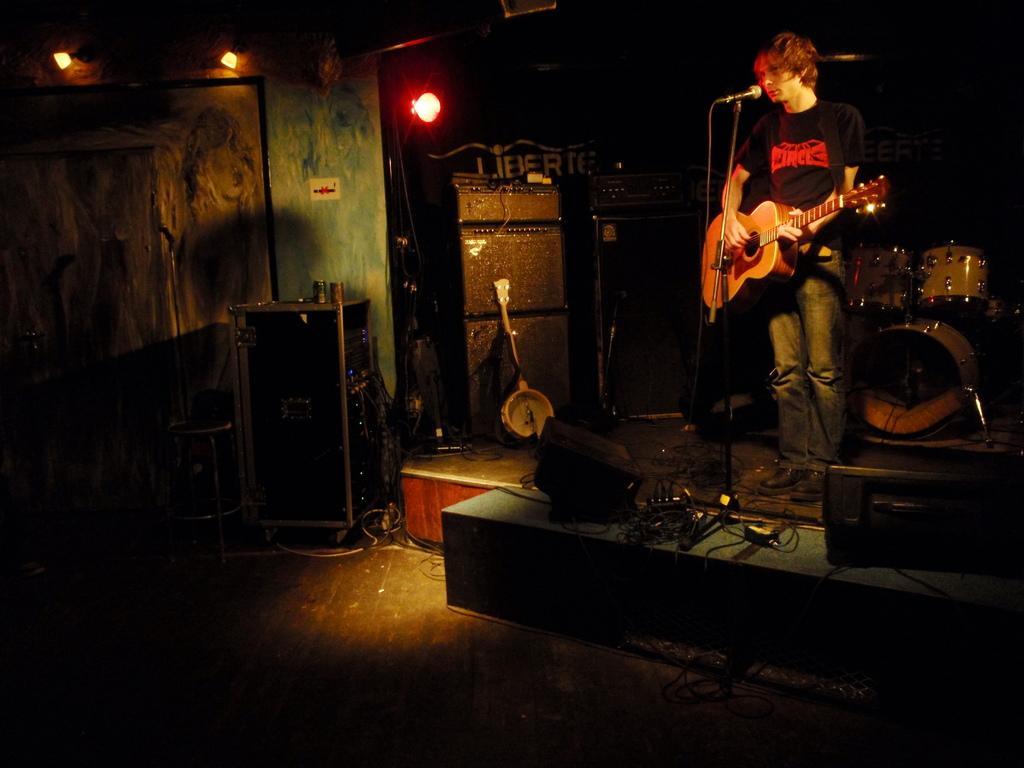How would you summarize this image in a sentence or two? On top there are lights. This man is playing guitar and singing in-front of mic. These are musical instruments. This is a box. These are speakers. 